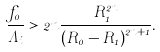<formula> <loc_0><loc_0><loc_500><loc_500>\frac { f _ { 0 } } { \Lambda _ { i } } > 2 n \frac { R _ { 1 } ^ { 2 n } } { \left ( R _ { 0 } - R _ { 1 } \right ) ^ { 2 n + 1 } } .</formula> 